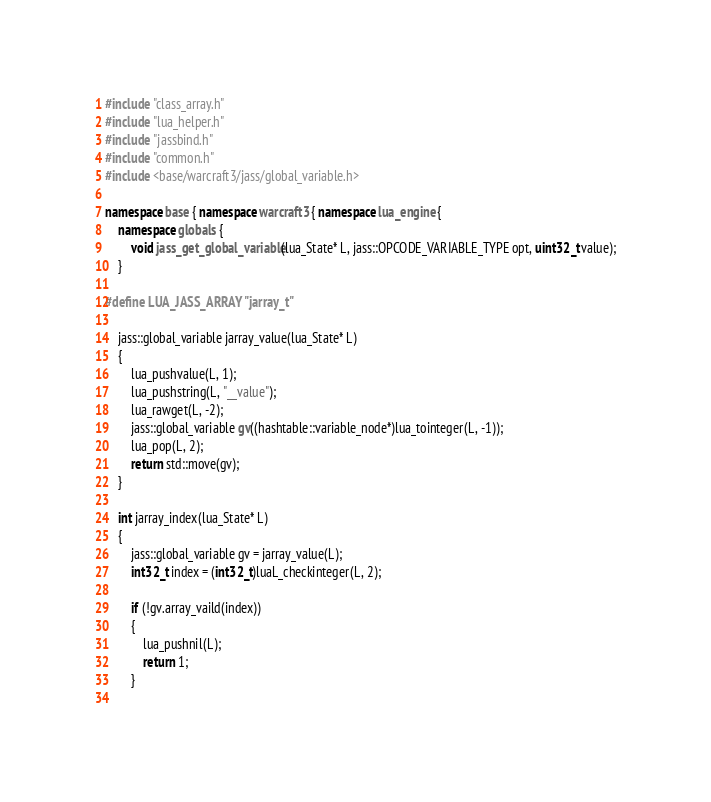<code> <loc_0><loc_0><loc_500><loc_500><_C++_>#include "class_array.h"
#include "lua_helper.h"
#include "jassbind.h"
#include "common.h"
#include <base/warcraft3/jass/global_variable.h>

namespace base { namespace warcraft3 { namespace lua_engine {
	namespace globals {
		void jass_get_global_variable(lua_State* L, jass::OPCODE_VARIABLE_TYPE opt, uint32_t value);
	}

#define LUA_JASS_ARRAY "jarray_t"

	jass::global_variable jarray_value(lua_State* L)
	{
		lua_pushvalue(L, 1);
		lua_pushstring(L, "__value");
		lua_rawget(L, -2);
		jass::global_variable gv((hashtable::variable_node*)lua_tointeger(L, -1));
		lua_pop(L, 2);
		return std::move(gv);
	}

	int jarray_index(lua_State* L)
	{
		jass::global_variable gv = jarray_value(L);
		int32_t index = (int32_t)luaL_checkinteger(L, 2);

		if (!gv.array_vaild(index))
		{
			lua_pushnil(L);
			return 1;
		}
	</code> 